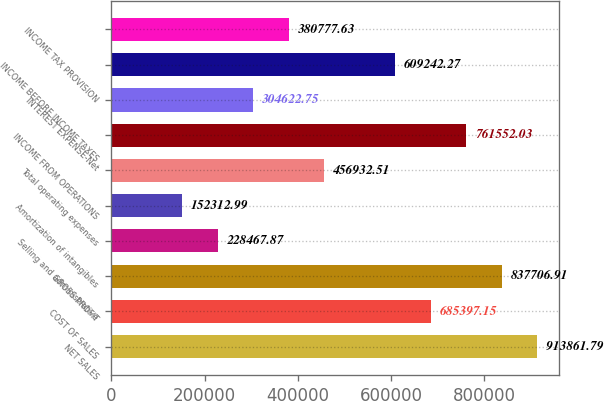Convert chart. <chart><loc_0><loc_0><loc_500><loc_500><bar_chart><fcel>NET SALES<fcel>COST OF SALES<fcel>GROSS PROFIT<fcel>Selling and administrative<fcel>Amortization of intangibles<fcel>Total operating expenses<fcel>INCOME FROM OPERATIONS<fcel>INTEREST EXPENSE-Net<fcel>INCOME BEFORE INCOME TAXES<fcel>INCOME TAX PROVISION<nl><fcel>913862<fcel>685397<fcel>837707<fcel>228468<fcel>152313<fcel>456933<fcel>761552<fcel>304623<fcel>609242<fcel>380778<nl></chart> 